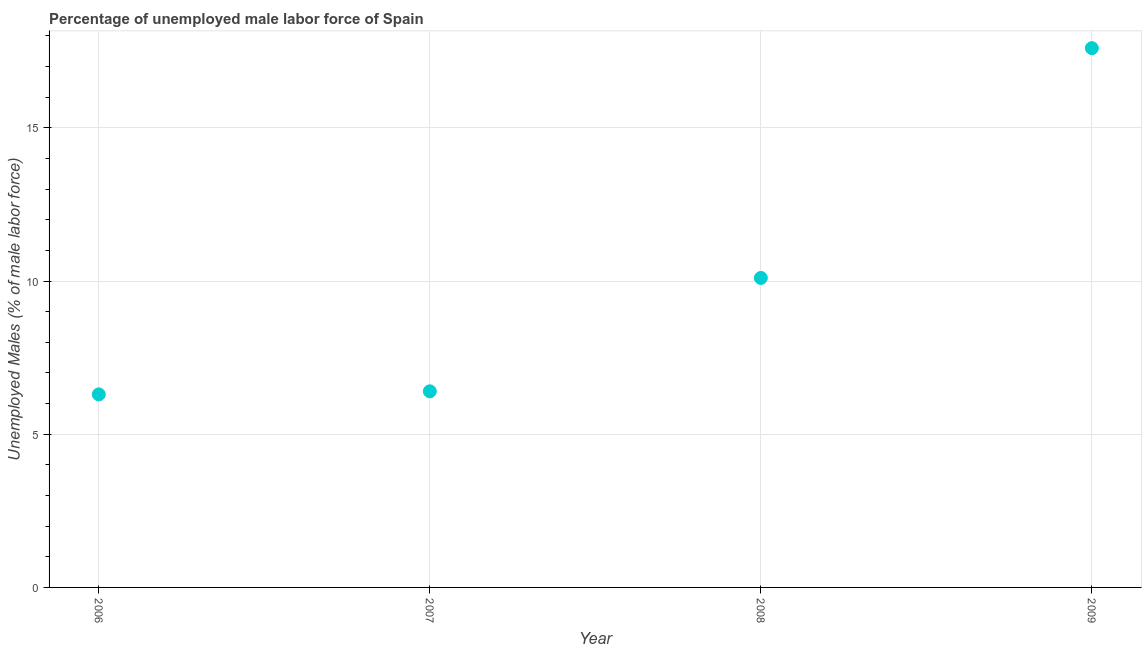What is the total unemployed male labour force in 2007?
Your answer should be compact. 6.4. Across all years, what is the maximum total unemployed male labour force?
Provide a succinct answer. 17.6. Across all years, what is the minimum total unemployed male labour force?
Your response must be concise. 6.3. In which year was the total unemployed male labour force maximum?
Provide a short and direct response. 2009. What is the sum of the total unemployed male labour force?
Provide a succinct answer. 40.4. What is the difference between the total unemployed male labour force in 2008 and 2009?
Your response must be concise. -7.5. What is the average total unemployed male labour force per year?
Provide a succinct answer. 10.1. What is the median total unemployed male labour force?
Ensure brevity in your answer.  8.25. Do a majority of the years between 2009 and 2006 (inclusive) have total unemployed male labour force greater than 11 %?
Offer a very short reply. Yes. What is the ratio of the total unemployed male labour force in 2008 to that in 2009?
Make the answer very short. 0.57. Is the total unemployed male labour force in 2007 less than that in 2009?
Your answer should be compact. Yes. What is the difference between the highest and the second highest total unemployed male labour force?
Make the answer very short. 7.5. Is the sum of the total unemployed male labour force in 2006 and 2008 greater than the maximum total unemployed male labour force across all years?
Provide a short and direct response. No. What is the difference between the highest and the lowest total unemployed male labour force?
Provide a succinct answer. 11.3. In how many years, is the total unemployed male labour force greater than the average total unemployed male labour force taken over all years?
Make the answer very short. 2. Are the values on the major ticks of Y-axis written in scientific E-notation?
Your response must be concise. No. Does the graph contain any zero values?
Offer a very short reply. No. What is the title of the graph?
Give a very brief answer. Percentage of unemployed male labor force of Spain. What is the label or title of the X-axis?
Offer a very short reply. Year. What is the label or title of the Y-axis?
Ensure brevity in your answer.  Unemployed Males (% of male labor force). What is the Unemployed Males (% of male labor force) in 2006?
Your answer should be very brief. 6.3. What is the Unemployed Males (% of male labor force) in 2007?
Your answer should be very brief. 6.4. What is the Unemployed Males (% of male labor force) in 2008?
Your response must be concise. 10.1. What is the Unemployed Males (% of male labor force) in 2009?
Offer a very short reply. 17.6. What is the difference between the Unemployed Males (% of male labor force) in 2006 and 2007?
Ensure brevity in your answer.  -0.1. What is the difference between the Unemployed Males (% of male labor force) in 2007 and 2008?
Your response must be concise. -3.7. What is the ratio of the Unemployed Males (% of male labor force) in 2006 to that in 2007?
Your response must be concise. 0.98. What is the ratio of the Unemployed Males (% of male labor force) in 2006 to that in 2008?
Offer a very short reply. 0.62. What is the ratio of the Unemployed Males (% of male labor force) in 2006 to that in 2009?
Offer a terse response. 0.36. What is the ratio of the Unemployed Males (% of male labor force) in 2007 to that in 2008?
Provide a short and direct response. 0.63. What is the ratio of the Unemployed Males (% of male labor force) in 2007 to that in 2009?
Give a very brief answer. 0.36. What is the ratio of the Unemployed Males (% of male labor force) in 2008 to that in 2009?
Provide a short and direct response. 0.57. 